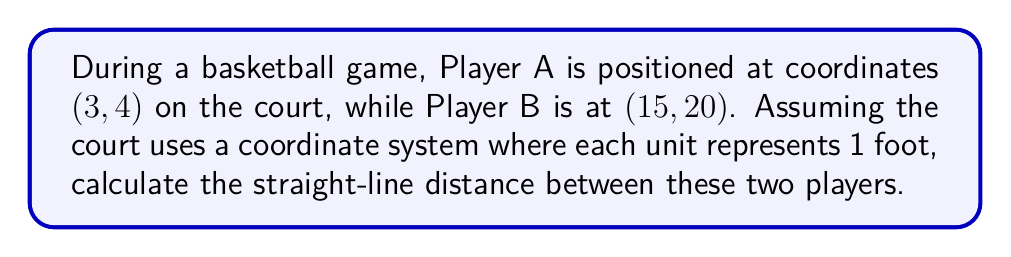Can you answer this question? To find the distance between two points on a coordinate plane, we can use the distance formula, which is derived from the Pythagorean theorem:

$$d = \sqrt{(x_2 - x_1)^2 + (y_2 - y_1)^2}$$

Where $(x_1, y_1)$ represents the coordinates of Player A, and $(x_2, y_2)$ represents the coordinates of Player B.

Let's plug in the values:
$(x_1, y_1) = (3, 4)$
$(x_2, y_2) = (15, 20)$

Now, let's solve step-by-step:

1) First, calculate the differences:
   $x_2 - x_1 = 15 - 3 = 12$
   $y_2 - y_1 = 20 - 4 = 16$

2) Square these differences:
   $(x_2 - x_1)^2 = 12^2 = 144$
   $(y_2 - y_1)^2 = 16^2 = 256$

3) Add the squared differences:
   $144 + 256 = 400$

4) Take the square root of the sum:
   $\sqrt{400} = 20$

Therefore, the distance between Player A and Player B is 20 feet.

[asy]
unitsize(10);
draw((0,0)--(20,25), gray);
dot((3,4));
dot((15,20));
label("Player A (3,4)", (3,4), SW);
label("Player B (15,20)", (15,20), NE);
label("20 ft", (9,12), SE);
[/asy]
Answer: 20 feet 